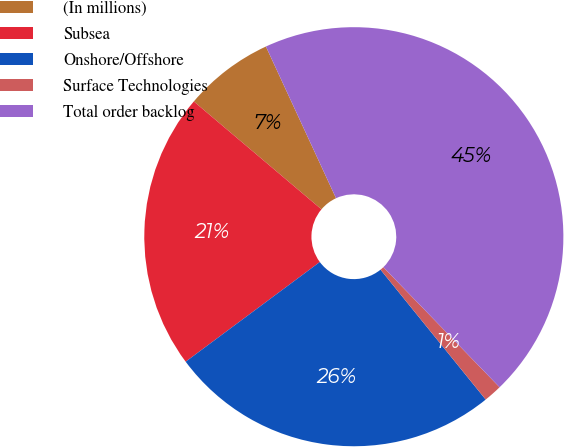<chart> <loc_0><loc_0><loc_500><loc_500><pie_chart><fcel>(In millions)<fcel>Subsea<fcel>Onshore/Offshore<fcel>Surface Technologies<fcel>Total order backlog<nl><fcel>6.94%<fcel>21.34%<fcel>25.66%<fcel>1.41%<fcel>44.65%<nl></chart> 